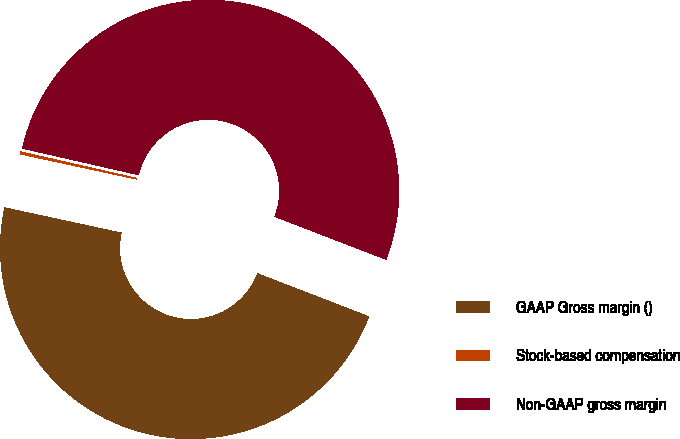<chart> <loc_0><loc_0><loc_500><loc_500><pie_chart><fcel>GAAP Gross margin ()<fcel>Stock-based compensation<fcel>Non-GAAP gross margin<nl><fcel>47.53%<fcel>0.19%<fcel>52.28%<nl></chart> 